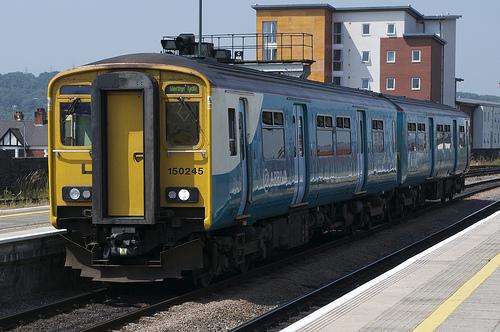Question: what color is the line on the bottom right?
Choices:
A. Green.
B. Orange.
C. Pale Yellow.
D. Red.
Answer with the letter. Answer: C Question: how many colors are on the buildings?
Choices:
A. 1.
B. 3.
C. 2.
D. 4.
Answer with the letter. Answer: B Question: what color is the building on the right?
Choices:
A. Blue.
B. Grey.
C. Green.
D. Red.
Answer with the letter. Answer: D 